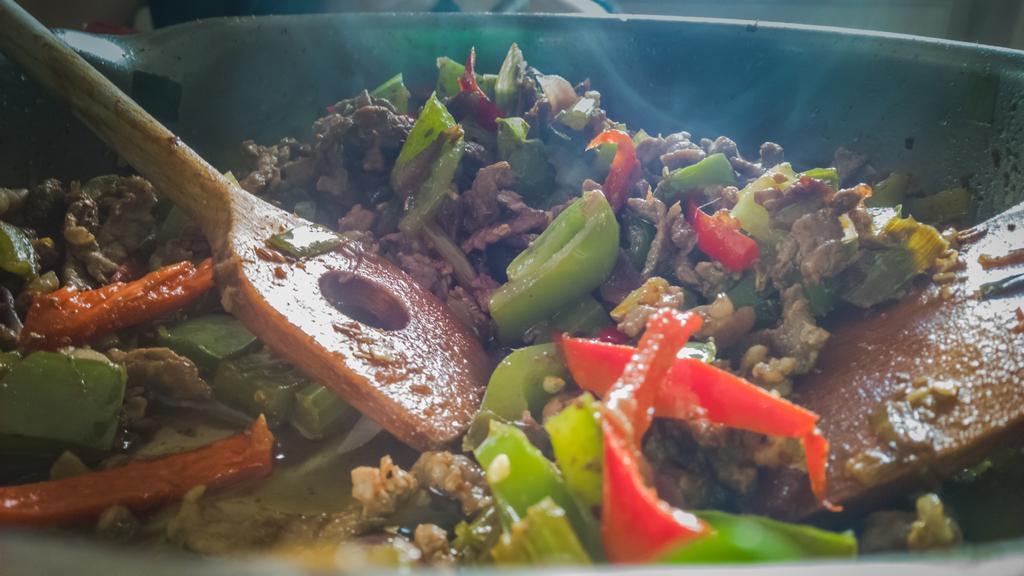Could you give a brief overview of what you see in this image? In this image we can see food in the bowl and ladles in it. 